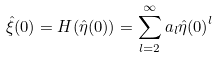Convert formula to latex. <formula><loc_0><loc_0><loc_500><loc_500>\hat { \xi } ( 0 ) = H ( \hat { \eta } ( 0 ) ) = \sum _ { l = 2 } ^ { \infty } a _ { l } { \hat { \eta } ( 0 ) } ^ { l }</formula> 